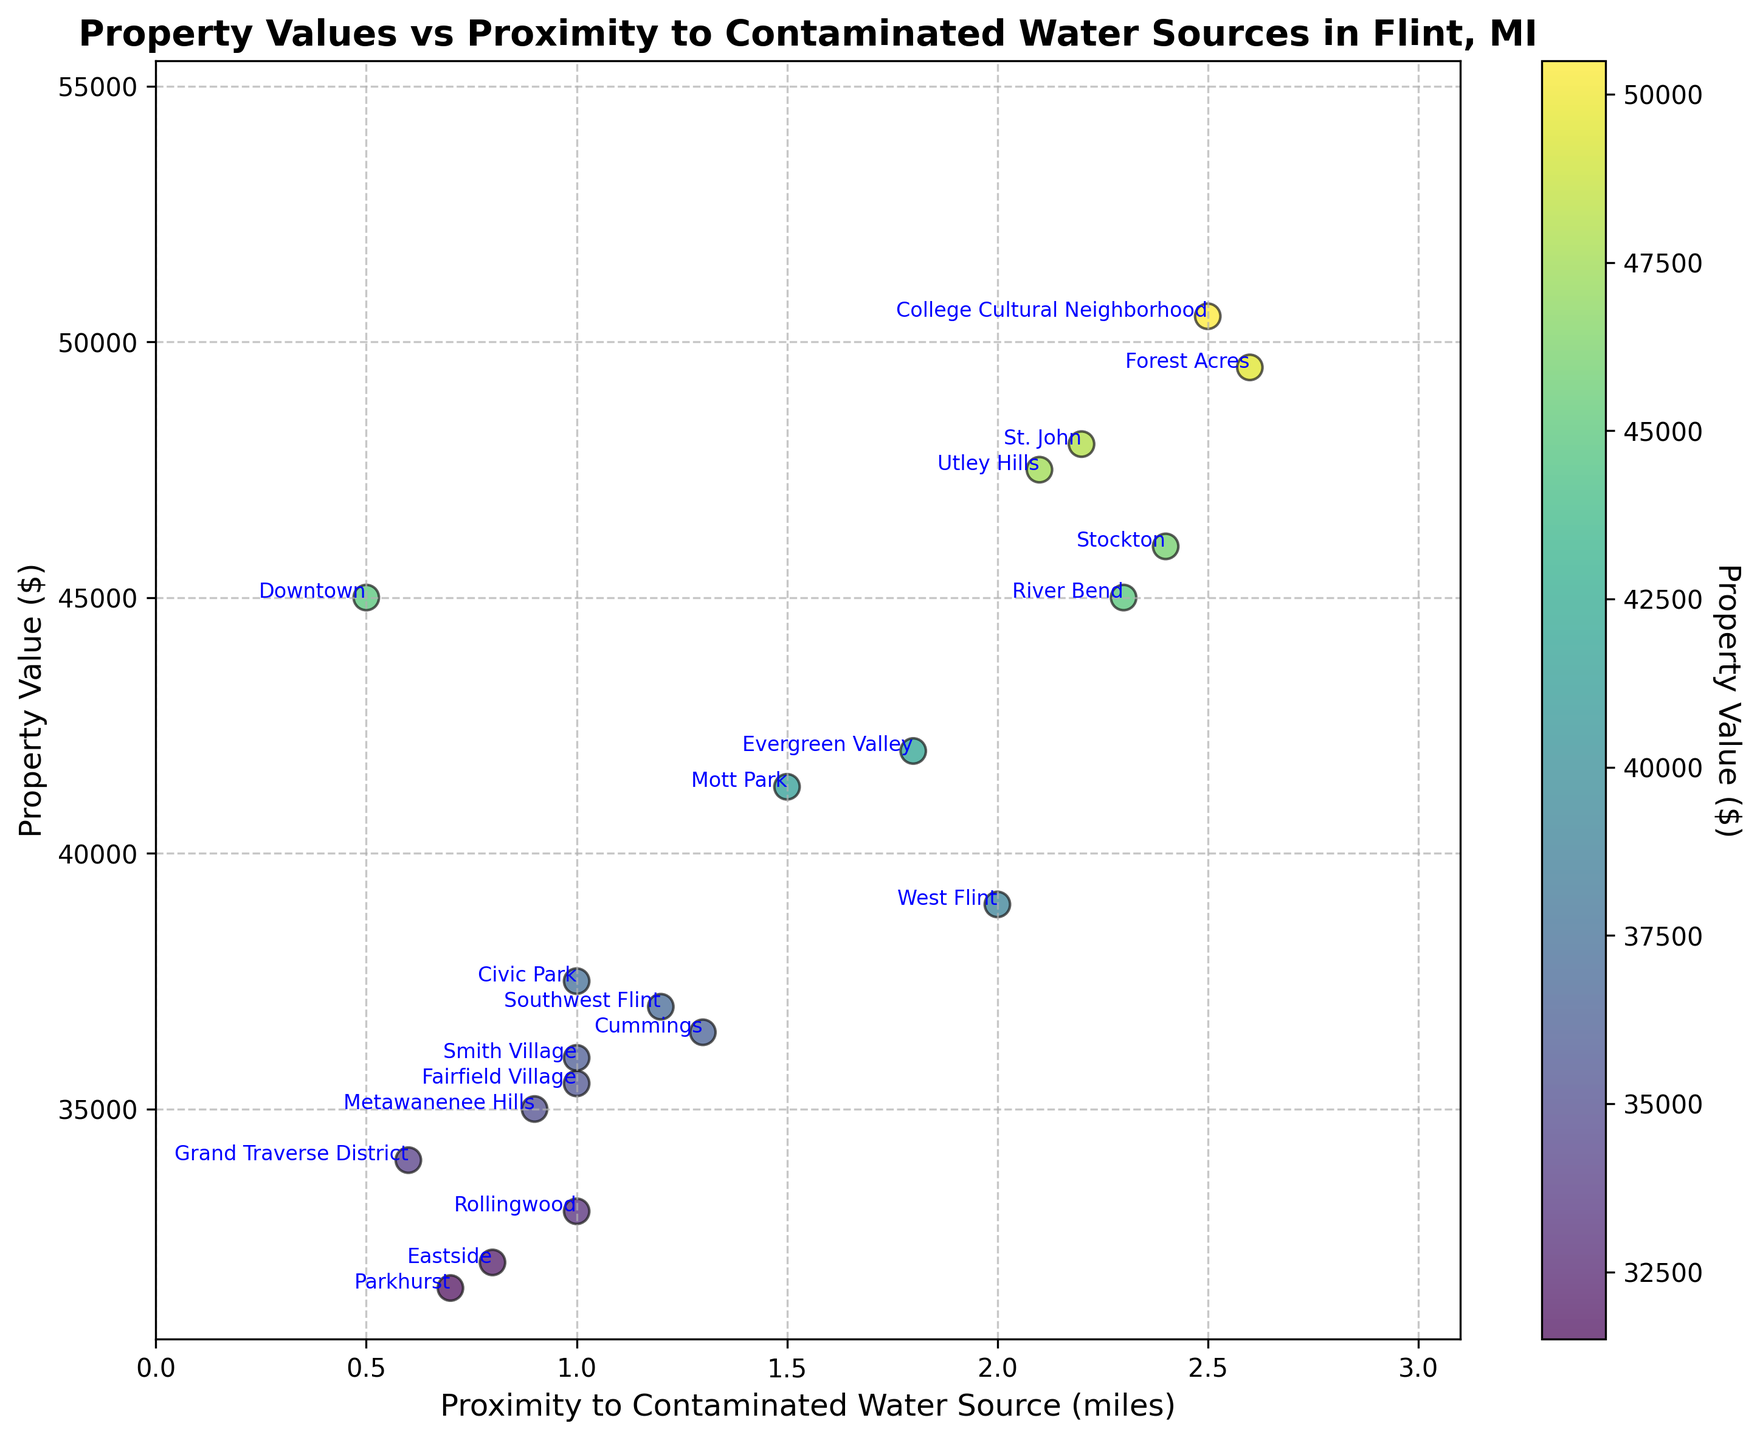Which neighborhood is closest to a contaminated water source and what is its property value? The neighborhood closest to a contaminated water source is identified by finding the lowest proximity value. The property value for this neighborhood is then noted. Downtown has the smallest proximity value of 0.5 miles and a property value of $45,000.
Answer: Downtown, $45,000 Which neighborhood is farthest from a contaminated water source and what is its property value? The neighborhood farthest from a contaminated water source is identified by finding the highest proximity value. The property value for this neighborhood is then noted. Forest Acres has the largest proximity value of 2.6 miles and a property value of $49,500.
Answer: Forest Acres, $49,500 Which neighborhood has the highest property value and how far is it from a contaminated water source? The neighborhood with the highest property value is identified by finding the maximum property value. The proximity to a contaminated water source for this neighborhood is then noted. College Cultural Neighborhood has the highest property value of $50,500 and a proximity of 2.5 miles.
Answer: College Cultural Neighborhood, 2.5 miles Which is the neighborhood with the lowest property value and what is its proximity to a contaminated water source? The neighborhood with the lowest property value is identified by finding the minimum property value. The proximity to a contaminated water source for this neighborhood is then noted. Parkhurst has the lowest property value of $31,500 and a proximity of 0.7 miles.
Answer: Parkhurst, 0.7 miles How does the property value change as the proximity to contaminated water sources increases? To find the trend, observe the general pattern of the data points. Property values generally appear to increase as the proximity to contaminated water sources increases.
Answer: Increases What is the average property value for neighborhoods within 1 mile of a contaminated water source? Add up the property values of Downtown, Civic Park, Eastside, Grand Traverse District, Metawanenee Hills, Smith Village, Rollingwood, and Parkhurst, then divide by the number of these neighborhoods. Total property value is $45,000 + $37,500 + $32,000 + $34,000 + $35,000 + $36,000 + $33,000 + $31,500 = $284,000. There are 8 neighborhoods, so average property value is $284,000 / 8 = $35,500.
Answer: $35,500 Compare the property values of neighborhoods within 1 mile proximity and those beyond 2 miles proximity to contaminated water sources. Calculate the average property value for neighborhoods within 1 mile and those beyond 2 miles proximity. Within 1 mile: $35,500 (calculated in previous step). Beyond 2 miles: College Cultural Neighborhood, St. John, River Bend, Utley Hills, Stockton, Forest Acres. Their property values are $50,500 + $48,000 + $45,000 + $47,500 + $46,000 + $49,500 = $286,500. There are 6 neighborhoods, so the average is $286,500 / 6 = $47,750.
Answer: $35,500 vs $47,750 What is the range of property values for neighborhoods within 1.5 miles of contaminated water sources? Identify the property values of neighborhoods within 1.5 miles. The values are for Downtown ($45,000), Civic Park ($37,500), Mott Park ($41,300), Eastside ($32,000), Southwest Flint ($37,000), Grand Traverse District ($34,000), Metawanenee Hills ($35,000), Cummings ($36,500), Smith Village ($36,000), Rollingwood ($33,000), and Parkhurst ($31,500). The highest is $45,000, and the lowest is $31,500. The range is $45,000 - $31,500 = $13,500.
Answer: $13,500 